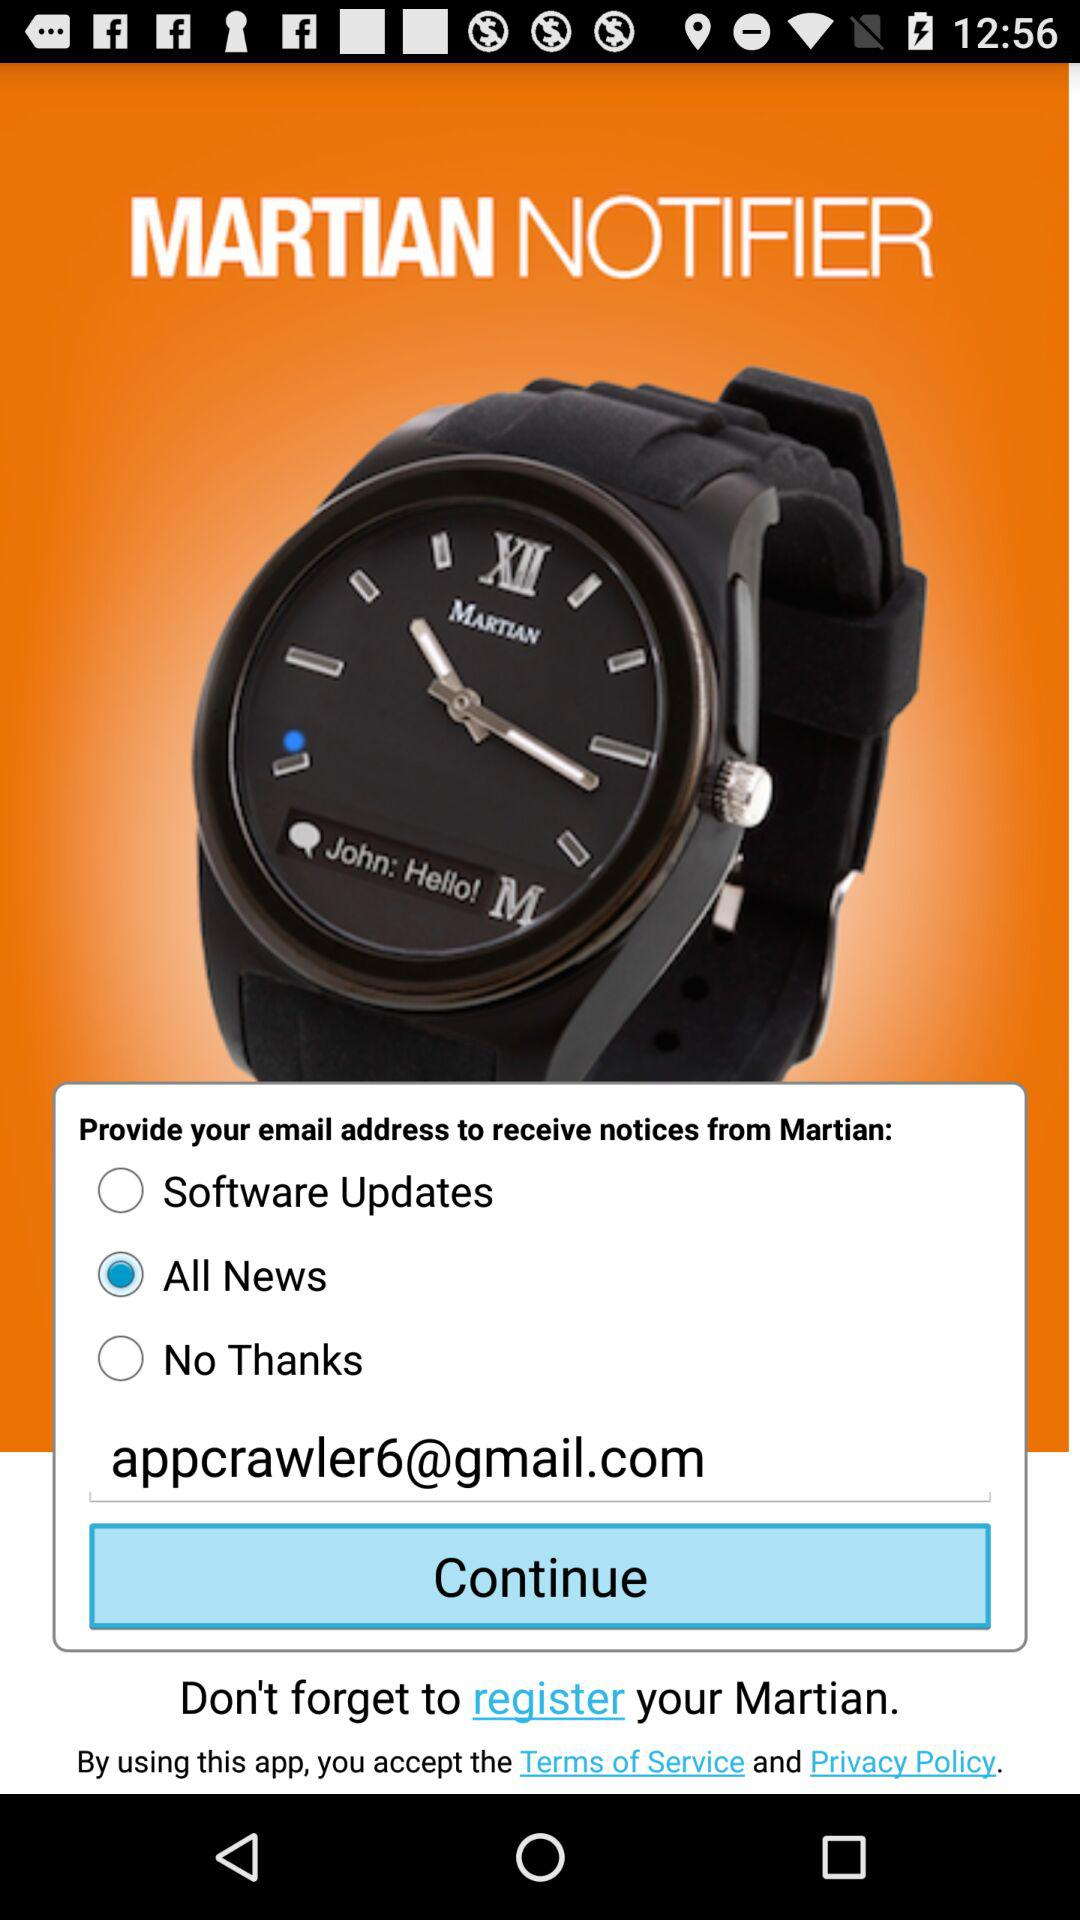What is the app name? The app name is "MARTIAN NOTIFIER". 